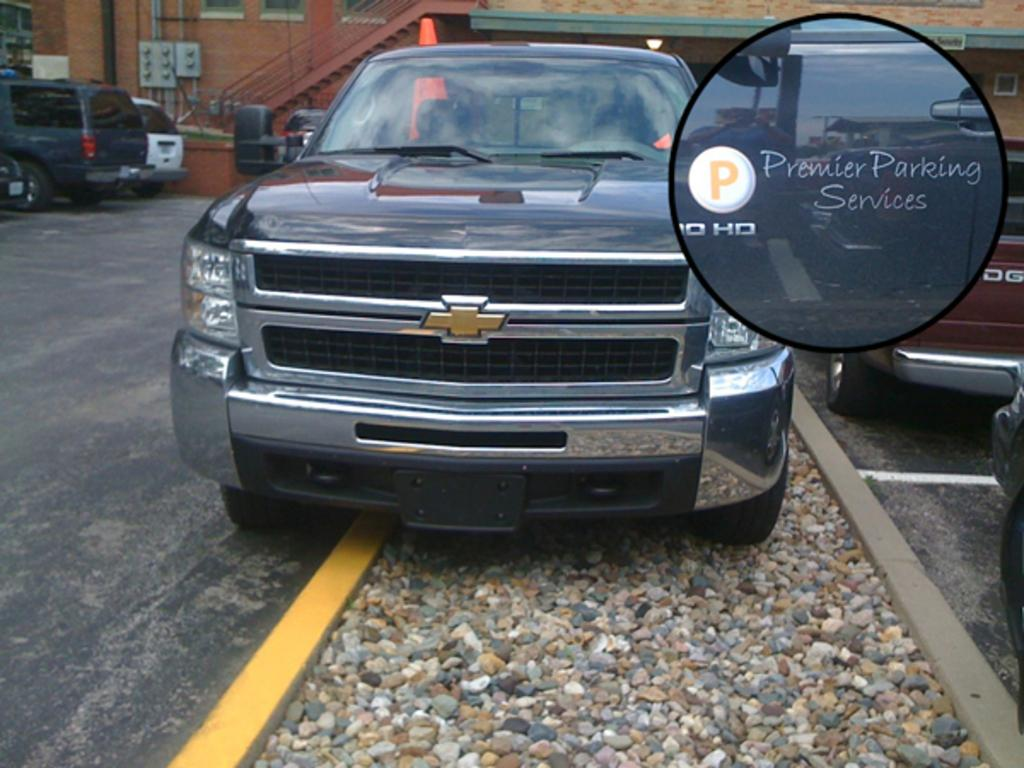What is happening on the road in the image? There are vehicles on the road in the image. Are there any obstacles on the road in the image? Yes, there are stones on the road in the image. What can be seen in the distance in the image? There are buildings visible in the background of the image. How does the wind affect the vehicles on the road in the image? There is no mention of wind in the image, so we cannot determine its effect on the vehicles. 